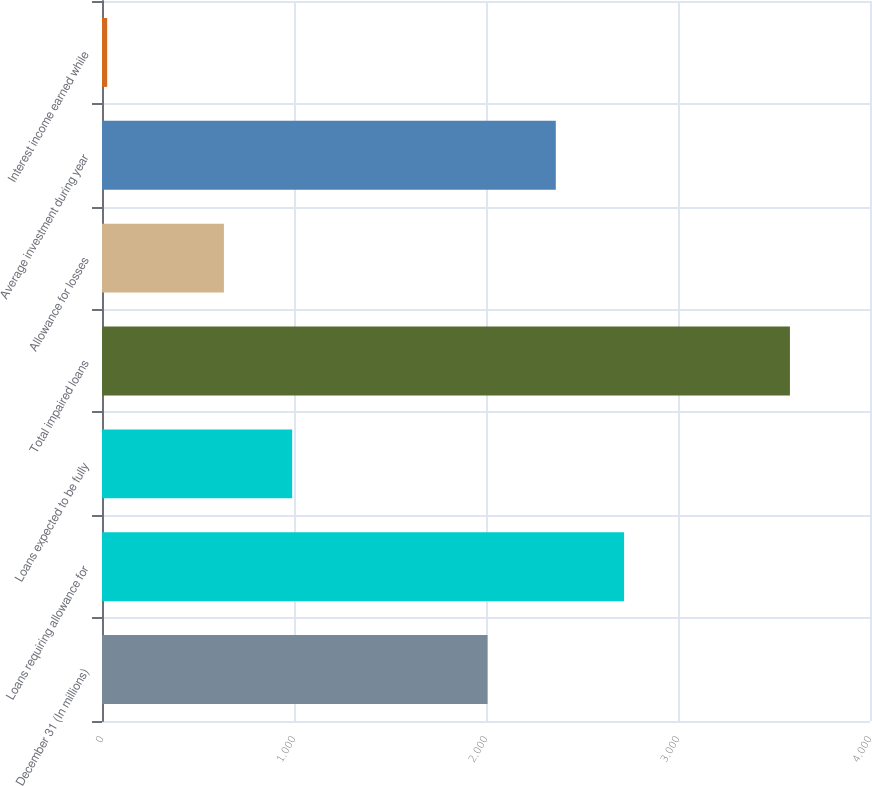Convert chart. <chart><loc_0><loc_0><loc_500><loc_500><bar_chart><fcel>December 31 (In millions)<fcel>Loans requiring allowance for<fcel>Loans expected to be fully<fcel>Total impaired loans<fcel>Allowance for losses<fcel>Average investment during year<fcel>Interest income earned while<nl><fcel>2008<fcel>2719.2<fcel>990.6<fcel>3583<fcel>635<fcel>2363.6<fcel>27<nl></chart> 